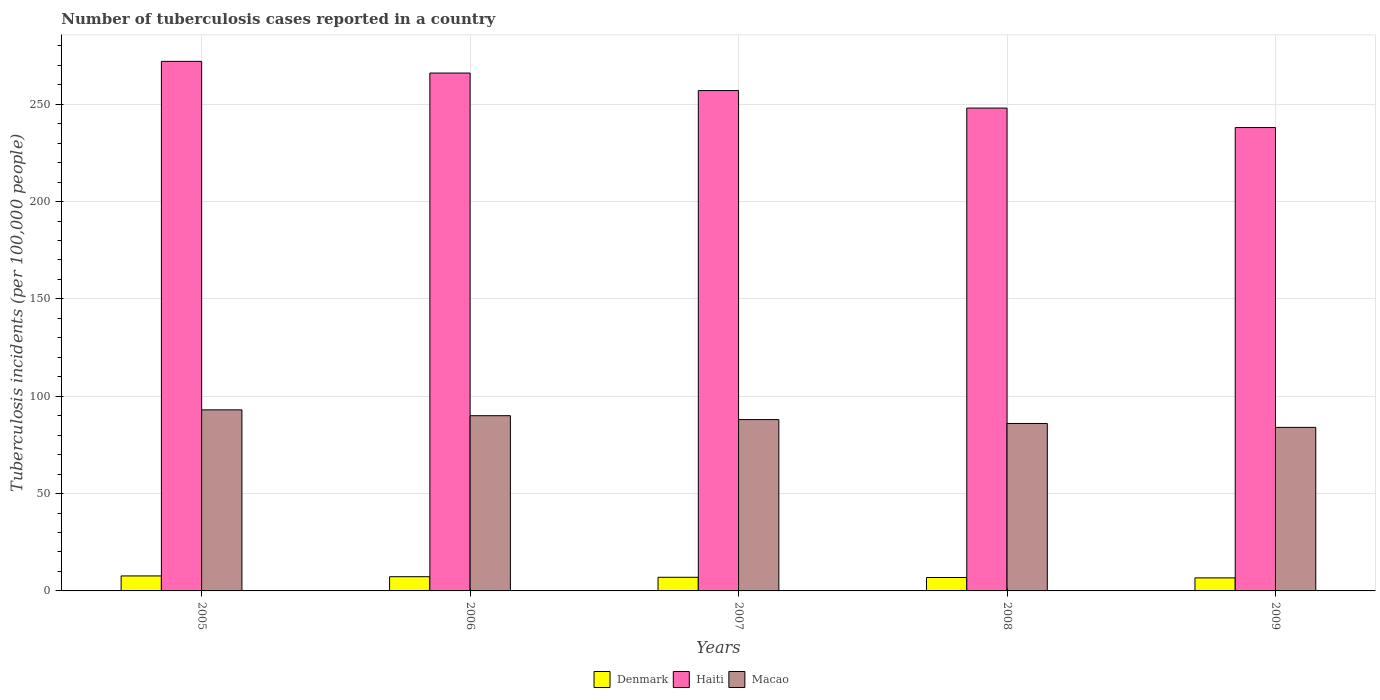How many different coloured bars are there?
Your response must be concise. 3. Are the number of bars per tick equal to the number of legend labels?
Keep it short and to the point. Yes. Are the number of bars on each tick of the X-axis equal?
Your answer should be very brief. Yes. In how many cases, is the number of bars for a given year not equal to the number of legend labels?
Keep it short and to the point. 0. Across all years, what is the maximum number of tuberculosis cases reported in in Macao?
Make the answer very short. 93. Across all years, what is the minimum number of tuberculosis cases reported in in Macao?
Ensure brevity in your answer.  84. What is the total number of tuberculosis cases reported in in Haiti in the graph?
Your answer should be compact. 1281. What is the difference between the number of tuberculosis cases reported in in Macao in 2007 and that in 2008?
Keep it short and to the point. 2. What is the difference between the number of tuberculosis cases reported in in Denmark in 2007 and the number of tuberculosis cases reported in in Haiti in 2009?
Give a very brief answer. -231. What is the average number of tuberculosis cases reported in in Macao per year?
Make the answer very short. 88.2. In the year 2007, what is the difference between the number of tuberculosis cases reported in in Haiti and number of tuberculosis cases reported in in Macao?
Your answer should be very brief. 169. What is the ratio of the number of tuberculosis cases reported in in Macao in 2008 to that in 2009?
Your answer should be compact. 1.02. Is the number of tuberculosis cases reported in in Haiti in 2005 less than that in 2008?
Give a very brief answer. No. What is the difference between the highest and the second highest number of tuberculosis cases reported in in Denmark?
Your answer should be very brief. 0.4. What is the difference between the highest and the lowest number of tuberculosis cases reported in in Denmark?
Offer a terse response. 1. In how many years, is the number of tuberculosis cases reported in in Macao greater than the average number of tuberculosis cases reported in in Macao taken over all years?
Your response must be concise. 2. Is the sum of the number of tuberculosis cases reported in in Haiti in 2007 and 2008 greater than the maximum number of tuberculosis cases reported in in Macao across all years?
Provide a short and direct response. Yes. What does the 3rd bar from the left in 2006 represents?
Make the answer very short. Macao. Is it the case that in every year, the sum of the number of tuberculosis cases reported in in Macao and number of tuberculosis cases reported in in Denmark is greater than the number of tuberculosis cases reported in in Haiti?
Provide a short and direct response. No. How many bars are there?
Provide a short and direct response. 15. Where does the legend appear in the graph?
Offer a terse response. Bottom center. How are the legend labels stacked?
Offer a very short reply. Horizontal. What is the title of the graph?
Provide a short and direct response. Number of tuberculosis cases reported in a country. What is the label or title of the Y-axis?
Give a very brief answer. Tuberculosis incidents (per 100,0 people). What is the Tuberculosis incidents (per 100,000 people) in Denmark in 2005?
Provide a succinct answer. 7.7. What is the Tuberculosis incidents (per 100,000 people) of Haiti in 2005?
Provide a succinct answer. 272. What is the Tuberculosis incidents (per 100,000 people) of Macao in 2005?
Ensure brevity in your answer.  93. What is the Tuberculosis incidents (per 100,000 people) of Haiti in 2006?
Ensure brevity in your answer.  266. What is the Tuberculosis incidents (per 100,000 people) of Haiti in 2007?
Offer a very short reply. 257. What is the Tuberculosis incidents (per 100,000 people) in Macao in 2007?
Your response must be concise. 88. What is the Tuberculosis incidents (per 100,000 people) in Denmark in 2008?
Offer a very short reply. 6.9. What is the Tuberculosis incidents (per 100,000 people) in Haiti in 2008?
Ensure brevity in your answer.  248. What is the Tuberculosis incidents (per 100,000 people) in Haiti in 2009?
Provide a short and direct response. 238. Across all years, what is the maximum Tuberculosis incidents (per 100,000 people) in Haiti?
Provide a short and direct response. 272. Across all years, what is the maximum Tuberculosis incidents (per 100,000 people) of Macao?
Ensure brevity in your answer.  93. Across all years, what is the minimum Tuberculosis incidents (per 100,000 people) of Denmark?
Your answer should be compact. 6.7. Across all years, what is the minimum Tuberculosis incidents (per 100,000 people) in Haiti?
Offer a very short reply. 238. Across all years, what is the minimum Tuberculosis incidents (per 100,000 people) of Macao?
Provide a succinct answer. 84. What is the total Tuberculosis incidents (per 100,000 people) of Denmark in the graph?
Your response must be concise. 35.6. What is the total Tuberculosis incidents (per 100,000 people) in Haiti in the graph?
Ensure brevity in your answer.  1281. What is the total Tuberculosis incidents (per 100,000 people) of Macao in the graph?
Your answer should be compact. 441. What is the difference between the Tuberculosis incidents (per 100,000 people) of Haiti in 2005 and that in 2006?
Your answer should be very brief. 6. What is the difference between the Tuberculosis incidents (per 100,000 people) in Macao in 2005 and that in 2006?
Make the answer very short. 3. What is the difference between the Tuberculosis incidents (per 100,000 people) in Denmark in 2005 and that in 2007?
Provide a succinct answer. 0.7. What is the difference between the Tuberculosis incidents (per 100,000 people) of Macao in 2005 and that in 2007?
Give a very brief answer. 5. What is the difference between the Tuberculosis incidents (per 100,000 people) of Denmark in 2005 and that in 2008?
Offer a very short reply. 0.8. What is the difference between the Tuberculosis incidents (per 100,000 people) of Macao in 2005 and that in 2009?
Offer a terse response. 9. What is the difference between the Tuberculosis incidents (per 100,000 people) in Macao in 2006 and that in 2008?
Your answer should be very brief. 4. What is the difference between the Tuberculosis incidents (per 100,000 people) in Denmark in 2006 and that in 2009?
Provide a succinct answer. 0.6. What is the difference between the Tuberculosis incidents (per 100,000 people) in Haiti in 2006 and that in 2009?
Ensure brevity in your answer.  28. What is the difference between the Tuberculosis incidents (per 100,000 people) of Macao in 2006 and that in 2009?
Keep it short and to the point. 6. What is the difference between the Tuberculosis incidents (per 100,000 people) of Denmark in 2007 and that in 2008?
Provide a succinct answer. 0.1. What is the difference between the Tuberculosis incidents (per 100,000 people) in Haiti in 2007 and that in 2008?
Offer a terse response. 9. What is the difference between the Tuberculosis incidents (per 100,000 people) in Denmark in 2005 and the Tuberculosis incidents (per 100,000 people) in Haiti in 2006?
Offer a very short reply. -258.3. What is the difference between the Tuberculosis incidents (per 100,000 people) of Denmark in 2005 and the Tuberculosis incidents (per 100,000 people) of Macao in 2006?
Give a very brief answer. -82.3. What is the difference between the Tuberculosis incidents (per 100,000 people) in Haiti in 2005 and the Tuberculosis incidents (per 100,000 people) in Macao in 2006?
Keep it short and to the point. 182. What is the difference between the Tuberculosis incidents (per 100,000 people) of Denmark in 2005 and the Tuberculosis incidents (per 100,000 people) of Haiti in 2007?
Ensure brevity in your answer.  -249.3. What is the difference between the Tuberculosis incidents (per 100,000 people) of Denmark in 2005 and the Tuberculosis incidents (per 100,000 people) of Macao in 2007?
Provide a short and direct response. -80.3. What is the difference between the Tuberculosis incidents (per 100,000 people) of Haiti in 2005 and the Tuberculosis incidents (per 100,000 people) of Macao in 2007?
Make the answer very short. 184. What is the difference between the Tuberculosis incidents (per 100,000 people) in Denmark in 2005 and the Tuberculosis incidents (per 100,000 people) in Haiti in 2008?
Give a very brief answer. -240.3. What is the difference between the Tuberculosis incidents (per 100,000 people) of Denmark in 2005 and the Tuberculosis incidents (per 100,000 people) of Macao in 2008?
Give a very brief answer. -78.3. What is the difference between the Tuberculosis incidents (per 100,000 people) in Haiti in 2005 and the Tuberculosis incidents (per 100,000 people) in Macao in 2008?
Offer a very short reply. 186. What is the difference between the Tuberculosis incidents (per 100,000 people) of Denmark in 2005 and the Tuberculosis incidents (per 100,000 people) of Haiti in 2009?
Your response must be concise. -230.3. What is the difference between the Tuberculosis incidents (per 100,000 people) in Denmark in 2005 and the Tuberculosis incidents (per 100,000 people) in Macao in 2009?
Your response must be concise. -76.3. What is the difference between the Tuberculosis incidents (per 100,000 people) of Haiti in 2005 and the Tuberculosis incidents (per 100,000 people) of Macao in 2009?
Provide a succinct answer. 188. What is the difference between the Tuberculosis incidents (per 100,000 people) in Denmark in 2006 and the Tuberculosis incidents (per 100,000 people) in Haiti in 2007?
Give a very brief answer. -249.7. What is the difference between the Tuberculosis incidents (per 100,000 people) in Denmark in 2006 and the Tuberculosis incidents (per 100,000 people) in Macao in 2007?
Ensure brevity in your answer.  -80.7. What is the difference between the Tuberculosis incidents (per 100,000 people) in Haiti in 2006 and the Tuberculosis incidents (per 100,000 people) in Macao in 2007?
Provide a succinct answer. 178. What is the difference between the Tuberculosis incidents (per 100,000 people) of Denmark in 2006 and the Tuberculosis incidents (per 100,000 people) of Haiti in 2008?
Make the answer very short. -240.7. What is the difference between the Tuberculosis incidents (per 100,000 people) of Denmark in 2006 and the Tuberculosis incidents (per 100,000 people) of Macao in 2008?
Give a very brief answer. -78.7. What is the difference between the Tuberculosis incidents (per 100,000 people) of Haiti in 2006 and the Tuberculosis incidents (per 100,000 people) of Macao in 2008?
Your answer should be very brief. 180. What is the difference between the Tuberculosis incidents (per 100,000 people) in Denmark in 2006 and the Tuberculosis incidents (per 100,000 people) in Haiti in 2009?
Ensure brevity in your answer.  -230.7. What is the difference between the Tuberculosis incidents (per 100,000 people) of Denmark in 2006 and the Tuberculosis incidents (per 100,000 people) of Macao in 2009?
Your answer should be compact. -76.7. What is the difference between the Tuberculosis incidents (per 100,000 people) in Haiti in 2006 and the Tuberculosis incidents (per 100,000 people) in Macao in 2009?
Your answer should be compact. 182. What is the difference between the Tuberculosis incidents (per 100,000 people) in Denmark in 2007 and the Tuberculosis incidents (per 100,000 people) in Haiti in 2008?
Make the answer very short. -241. What is the difference between the Tuberculosis incidents (per 100,000 people) of Denmark in 2007 and the Tuberculosis incidents (per 100,000 people) of Macao in 2008?
Give a very brief answer. -79. What is the difference between the Tuberculosis incidents (per 100,000 people) in Haiti in 2007 and the Tuberculosis incidents (per 100,000 people) in Macao in 2008?
Provide a succinct answer. 171. What is the difference between the Tuberculosis incidents (per 100,000 people) of Denmark in 2007 and the Tuberculosis incidents (per 100,000 people) of Haiti in 2009?
Give a very brief answer. -231. What is the difference between the Tuberculosis incidents (per 100,000 people) in Denmark in 2007 and the Tuberculosis incidents (per 100,000 people) in Macao in 2009?
Your answer should be compact. -77. What is the difference between the Tuberculosis incidents (per 100,000 people) of Haiti in 2007 and the Tuberculosis incidents (per 100,000 people) of Macao in 2009?
Offer a very short reply. 173. What is the difference between the Tuberculosis incidents (per 100,000 people) of Denmark in 2008 and the Tuberculosis incidents (per 100,000 people) of Haiti in 2009?
Your answer should be very brief. -231.1. What is the difference between the Tuberculosis incidents (per 100,000 people) in Denmark in 2008 and the Tuberculosis incidents (per 100,000 people) in Macao in 2009?
Provide a succinct answer. -77.1. What is the difference between the Tuberculosis incidents (per 100,000 people) in Haiti in 2008 and the Tuberculosis incidents (per 100,000 people) in Macao in 2009?
Provide a succinct answer. 164. What is the average Tuberculosis incidents (per 100,000 people) in Denmark per year?
Provide a short and direct response. 7.12. What is the average Tuberculosis incidents (per 100,000 people) of Haiti per year?
Offer a terse response. 256.2. What is the average Tuberculosis incidents (per 100,000 people) of Macao per year?
Provide a succinct answer. 88.2. In the year 2005, what is the difference between the Tuberculosis incidents (per 100,000 people) of Denmark and Tuberculosis incidents (per 100,000 people) of Haiti?
Provide a succinct answer. -264.3. In the year 2005, what is the difference between the Tuberculosis incidents (per 100,000 people) of Denmark and Tuberculosis incidents (per 100,000 people) of Macao?
Your answer should be very brief. -85.3. In the year 2005, what is the difference between the Tuberculosis incidents (per 100,000 people) in Haiti and Tuberculosis incidents (per 100,000 people) in Macao?
Your response must be concise. 179. In the year 2006, what is the difference between the Tuberculosis incidents (per 100,000 people) in Denmark and Tuberculosis incidents (per 100,000 people) in Haiti?
Your response must be concise. -258.7. In the year 2006, what is the difference between the Tuberculosis incidents (per 100,000 people) in Denmark and Tuberculosis incidents (per 100,000 people) in Macao?
Offer a very short reply. -82.7. In the year 2006, what is the difference between the Tuberculosis incidents (per 100,000 people) in Haiti and Tuberculosis incidents (per 100,000 people) in Macao?
Provide a short and direct response. 176. In the year 2007, what is the difference between the Tuberculosis incidents (per 100,000 people) in Denmark and Tuberculosis incidents (per 100,000 people) in Haiti?
Keep it short and to the point. -250. In the year 2007, what is the difference between the Tuberculosis incidents (per 100,000 people) of Denmark and Tuberculosis incidents (per 100,000 people) of Macao?
Keep it short and to the point. -81. In the year 2007, what is the difference between the Tuberculosis incidents (per 100,000 people) of Haiti and Tuberculosis incidents (per 100,000 people) of Macao?
Offer a terse response. 169. In the year 2008, what is the difference between the Tuberculosis incidents (per 100,000 people) of Denmark and Tuberculosis incidents (per 100,000 people) of Haiti?
Your answer should be very brief. -241.1. In the year 2008, what is the difference between the Tuberculosis incidents (per 100,000 people) of Denmark and Tuberculosis incidents (per 100,000 people) of Macao?
Ensure brevity in your answer.  -79.1. In the year 2008, what is the difference between the Tuberculosis incidents (per 100,000 people) of Haiti and Tuberculosis incidents (per 100,000 people) of Macao?
Offer a terse response. 162. In the year 2009, what is the difference between the Tuberculosis incidents (per 100,000 people) of Denmark and Tuberculosis incidents (per 100,000 people) of Haiti?
Keep it short and to the point. -231.3. In the year 2009, what is the difference between the Tuberculosis incidents (per 100,000 people) of Denmark and Tuberculosis incidents (per 100,000 people) of Macao?
Ensure brevity in your answer.  -77.3. In the year 2009, what is the difference between the Tuberculosis incidents (per 100,000 people) of Haiti and Tuberculosis incidents (per 100,000 people) of Macao?
Ensure brevity in your answer.  154. What is the ratio of the Tuberculosis incidents (per 100,000 people) of Denmark in 2005 to that in 2006?
Offer a terse response. 1.05. What is the ratio of the Tuberculosis incidents (per 100,000 people) in Haiti in 2005 to that in 2006?
Your response must be concise. 1.02. What is the ratio of the Tuberculosis incidents (per 100,000 people) of Macao in 2005 to that in 2006?
Make the answer very short. 1.03. What is the ratio of the Tuberculosis incidents (per 100,000 people) of Haiti in 2005 to that in 2007?
Your answer should be very brief. 1.06. What is the ratio of the Tuberculosis incidents (per 100,000 people) in Macao in 2005 to that in 2007?
Your answer should be compact. 1.06. What is the ratio of the Tuberculosis incidents (per 100,000 people) in Denmark in 2005 to that in 2008?
Offer a very short reply. 1.12. What is the ratio of the Tuberculosis incidents (per 100,000 people) of Haiti in 2005 to that in 2008?
Offer a terse response. 1.1. What is the ratio of the Tuberculosis incidents (per 100,000 people) in Macao in 2005 to that in 2008?
Your response must be concise. 1.08. What is the ratio of the Tuberculosis incidents (per 100,000 people) of Denmark in 2005 to that in 2009?
Your answer should be very brief. 1.15. What is the ratio of the Tuberculosis incidents (per 100,000 people) in Haiti in 2005 to that in 2009?
Your response must be concise. 1.14. What is the ratio of the Tuberculosis incidents (per 100,000 people) of Macao in 2005 to that in 2009?
Provide a succinct answer. 1.11. What is the ratio of the Tuberculosis incidents (per 100,000 people) of Denmark in 2006 to that in 2007?
Ensure brevity in your answer.  1.04. What is the ratio of the Tuberculosis incidents (per 100,000 people) of Haiti in 2006 to that in 2007?
Make the answer very short. 1.03. What is the ratio of the Tuberculosis incidents (per 100,000 people) in Macao in 2006 to that in 2007?
Keep it short and to the point. 1.02. What is the ratio of the Tuberculosis incidents (per 100,000 people) of Denmark in 2006 to that in 2008?
Your response must be concise. 1.06. What is the ratio of the Tuberculosis incidents (per 100,000 people) in Haiti in 2006 to that in 2008?
Provide a succinct answer. 1.07. What is the ratio of the Tuberculosis incidents (per 100,000 people) in Macao in 2006 to that in 2008?
Give a very brief answer. 1.05. What is the ratio of the Tuberculosis incidents (per 100,000 people) of Denmark in 2006 to that in 2009?
Provide a short and direct response. 1.09. What is the ratio of the Tuberculosis incidents (per 100,000 people) of Haiti in 2006 to that in 2009?
Your response must be concise. 1.12. What is the ratio of the Tuberculosis incidents (per 100,000 people) of Macao in 2006 to that in 2009?
Provide a short and direct response. 1.07. What is the ratio of the Tuberculosis incidents (per 100,000 people) in Denmark in 2007 to that in 2008?
Ensure brevity in your answer.  1.01. What is the ratio of the Tuberculosis incidents (per 100,000 people) in Haiti in 2007 to that in 2008?
Your answer should be compact. 1.04. What is the ratio of the Tuberculosis incidents (per 100,000 people) in Macao in 2007 to that in 2008?
Your answer should be compact. 1.02. What is the ratio of the Tuberculosis incidents (per 100,000 people) of Denmark in 2007 to that in 2009?
Keep it short and to the point. 1.04. What is the ratio of the Tuberculosis incidents (per 100,000 people) in Haiti in 2007 to that in 2009?
Your response must be concise. 1.08. What is the ratio of the Tuberculosis incidents (per 100,000 people) in Macao in 2007 to that in 2009?
Offer a very short reply. 1.05. What is the ratio of the Tuberculosis incidents (per 100,000 people) of Denmark in 2008 to that in 2009?
Give a very brief answer. 1.03. What is the ratio of the Tuberculosis incidents (per 100,000 people) in Haiti in 2008 to that in 2009?
Provide a short and direct response. 1.04. What is the ratio of the Tuberculosis incidents (per 100,000 people) in Macao in 2008 to that in 2009?
Make the answer very short. 1.02. What is the difference between the highest and the second highest Tuberculosis incidents (per 100,000 people) of Denmark?
Your answer should be compact. 0.4. 